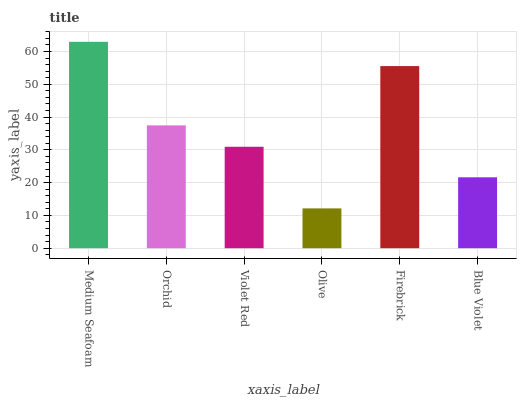Is Olive the minimum?
Answer yes or no. Yes. Is Medium Seafoam the maximum?
Answer yes or no. Yes. Is Orchid the minimum?
Answer yes or no. No. Is Orchid the maximum?
Answer yes or no. No. Is Medium Seafoam greater than Orchid?
Answer yes or no. Yes. Is Orchid less than Medium Seafoam?
Answer yes or no. Yes. Is Orchid greater than Medium Seafoam?
Answer yes or no. No. Is Medium Seafoam less than Orchid?
Answer yes or no. No. Is Orchid the high median?
Answer yes or no. Yes. Is Violet Red the low median?
Answer yes or no. Yes. Is Medium Seafoam the high median?
Answer yes or no. No. Is Medium Seafoam the low median?
Answer yes or no. No. 